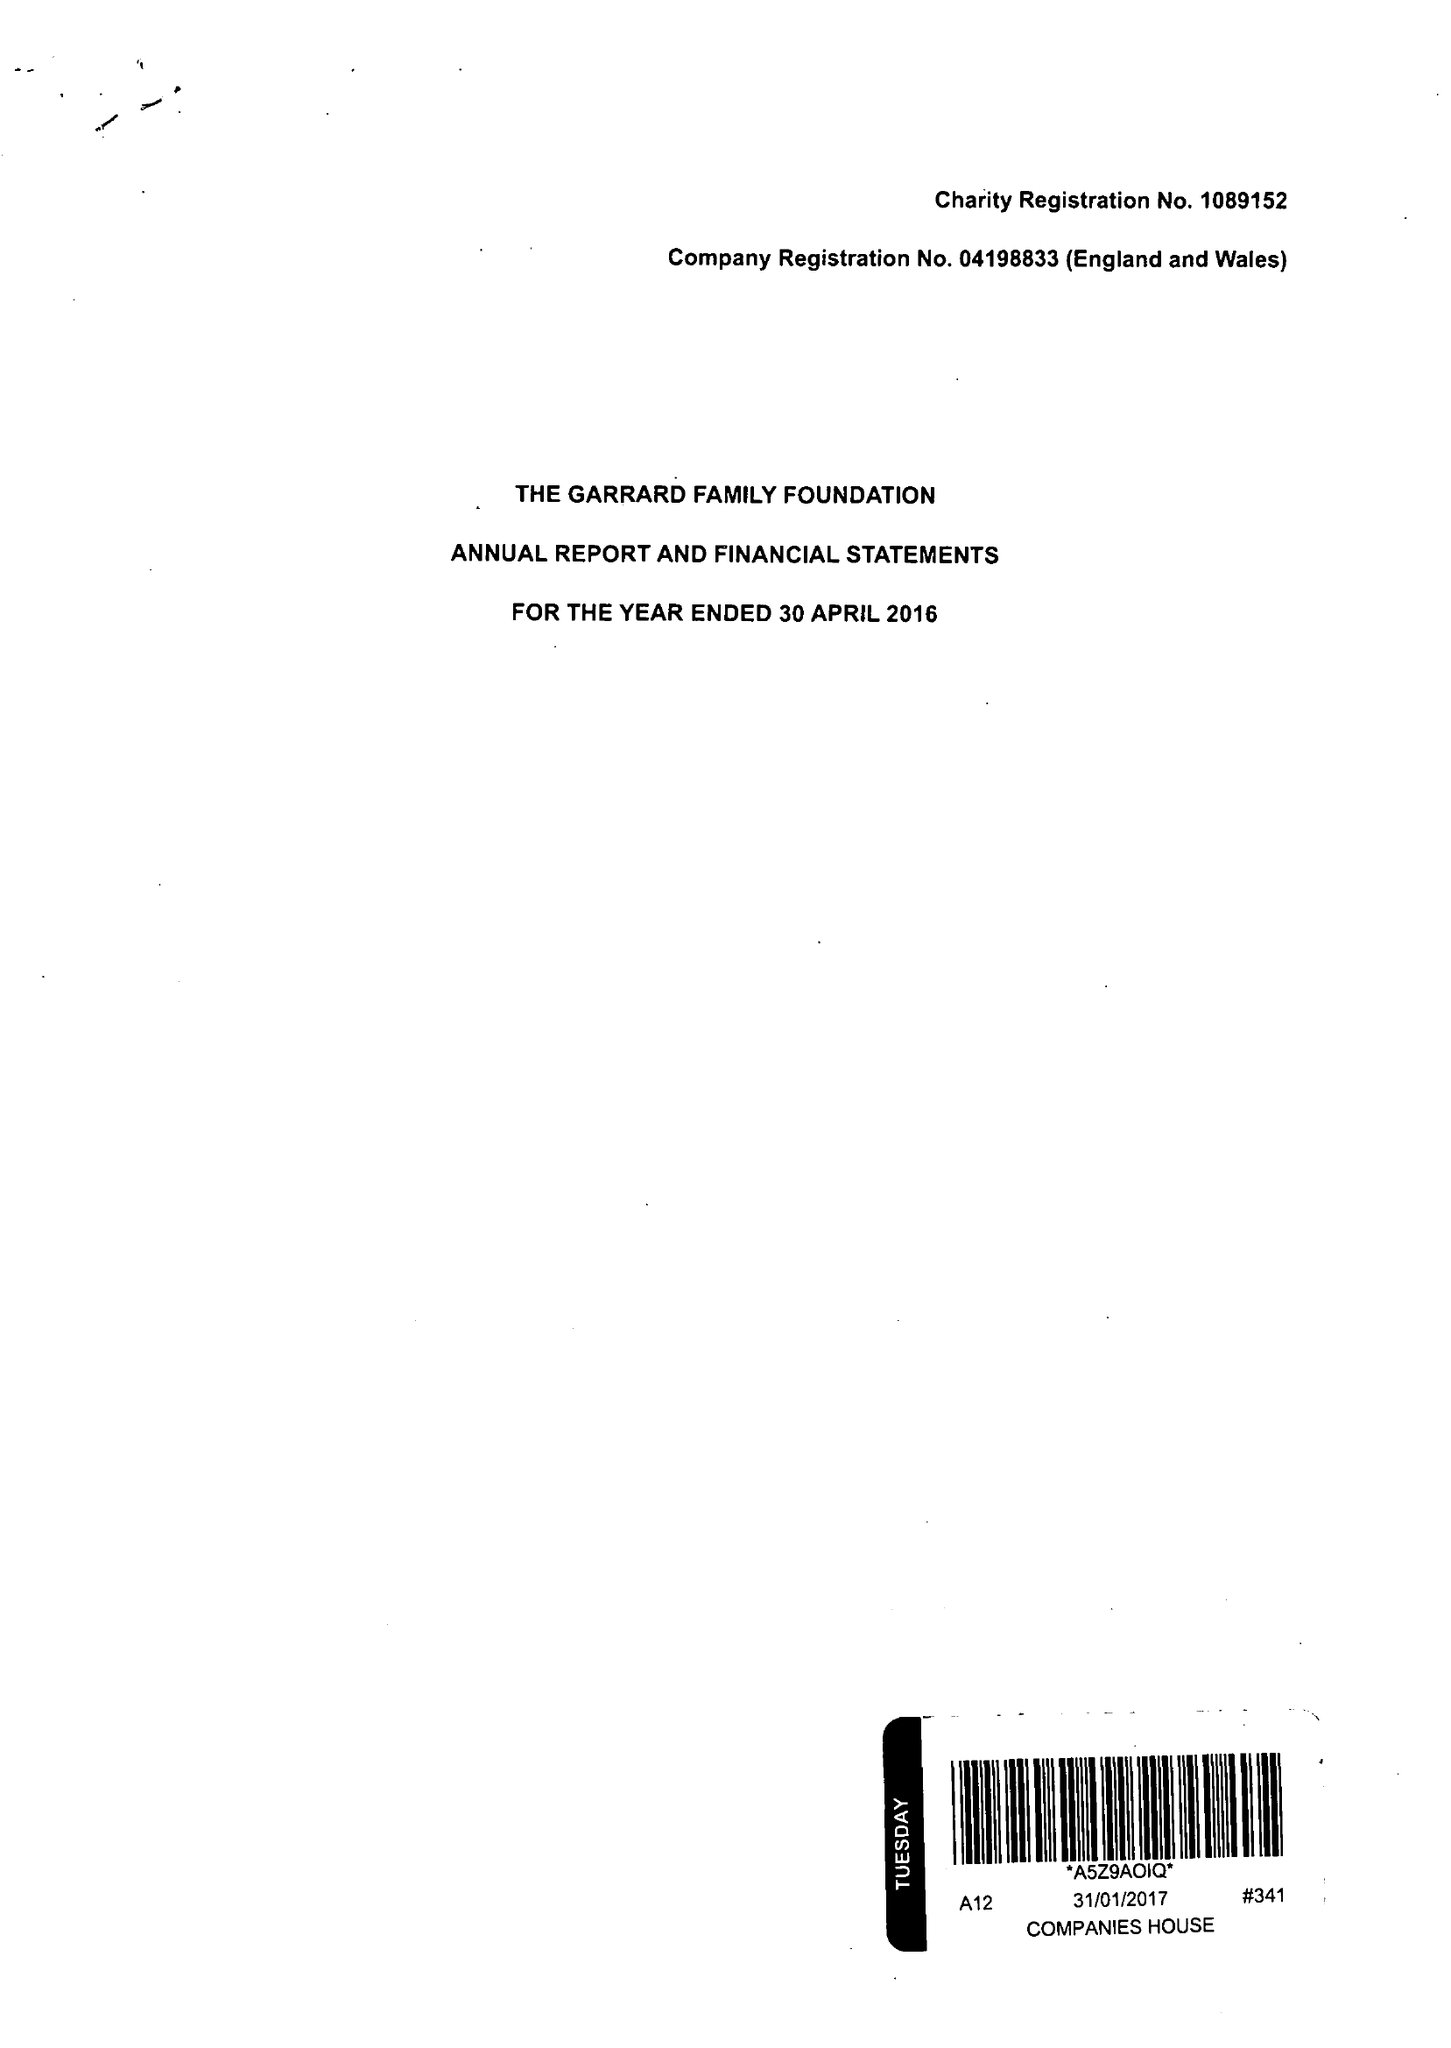What is the value for the income_annually_in_british_pounds?
Answer the question using a single word or phrase. 236572.00 